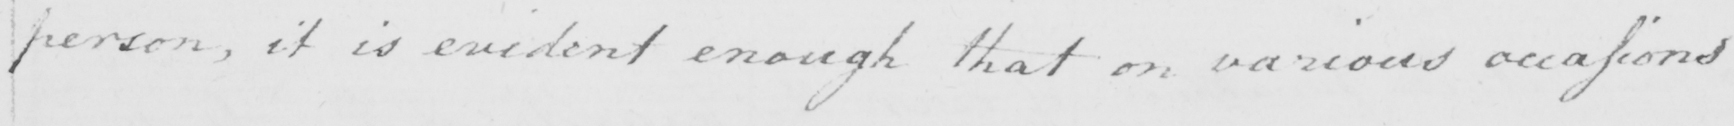Transcribe the text shown in this historical manuscript line. person , it is evident enough that on various occasions 